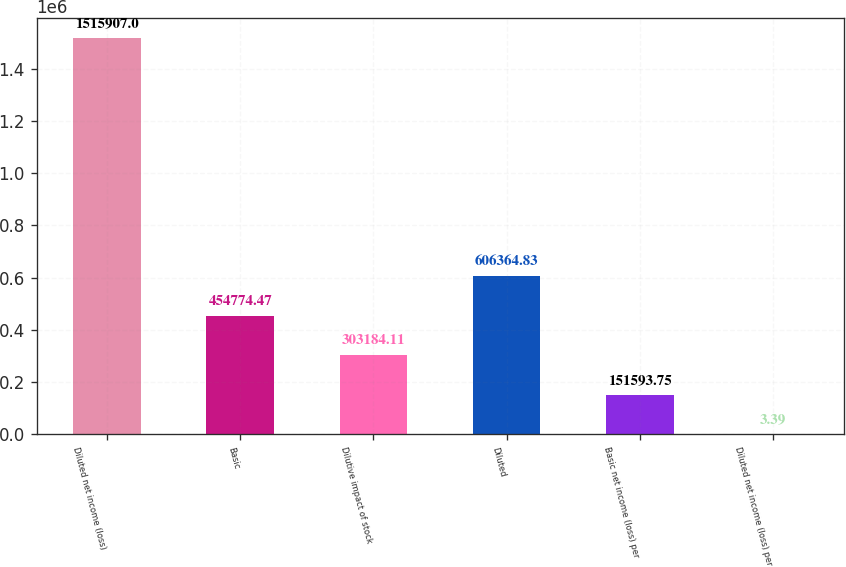<chart> <loc_0><loc_0><loc_500><loc_500><bar_chart><fcel>Diluted net income (loss)<fcel>Basic<fcel>Dilutive impact of stock<fcel>Diluted<fcel>Basic net income (loss) per<fcel>Diluted net income (loss) per<nl><fcel>1.51591e+06<fcel>454774<fcel>303184<fcel>606365<fcel>151594<fcel>3.39<nl></chart> 